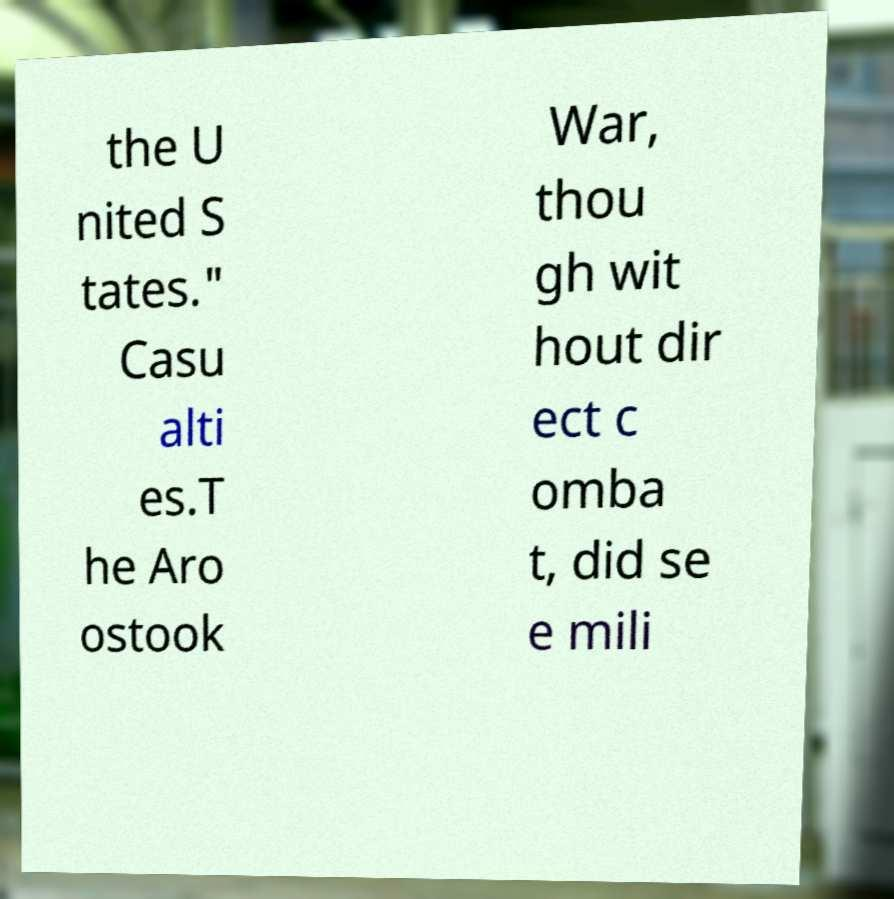There's text embedded in this image that I need extracted. Can you transcribe it verbatim? the U nited S tates." Casu alti es.T he Aro ostook War, thou gh wit hout dir ect c omba t, did se e mili 